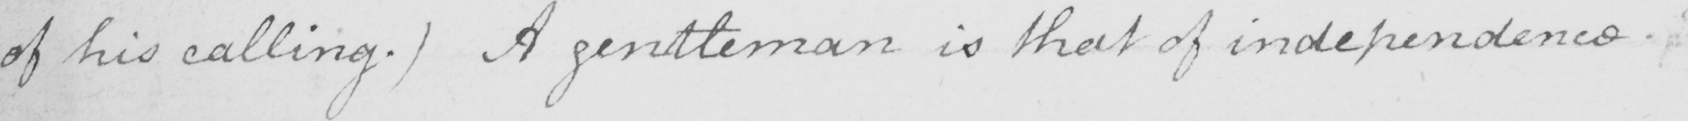What text is written in this handwritten line? of his calling . )  A gentleman is that of independence . 